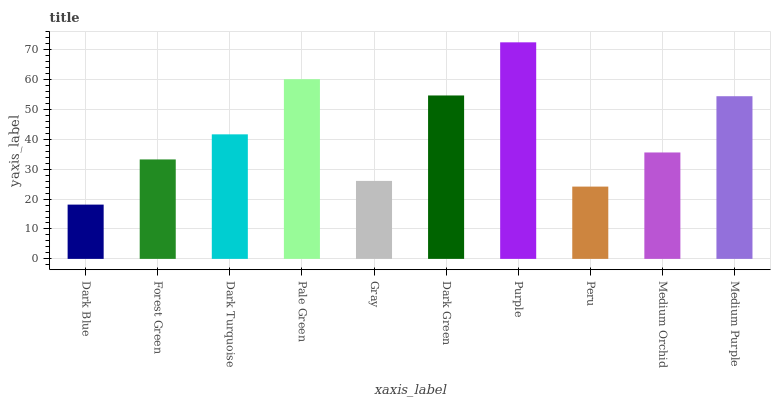Is Dark Blue the minimum?
Answer yes or no. Yes. Is Purple the maximum?
Answer yes or no. Yes. Is Forest Green the minimum?
Answer yes or no. No. Is Forest Green the maximum?
Answer yes or no. No. Is Forest Green greater than Dark Blue?
Answer yes or no. Yes. Is Dark Blue less than Forest Green?
Answer yes or no. Yes. Is Dark Blue greater than Forest Green?
Answer yes or no. No. Is Forest Green less than Dark Blue?
Answer yes or no. No. Is Dark Turquoise the high median?
Answer yes or no. Yes. Is Medium Orchid the low median?
Answer yes or no. Yes. Is Medium Orchid the high median?
Answer yes or no. No. Is Purple the low median?
Answer yes or no. No. 